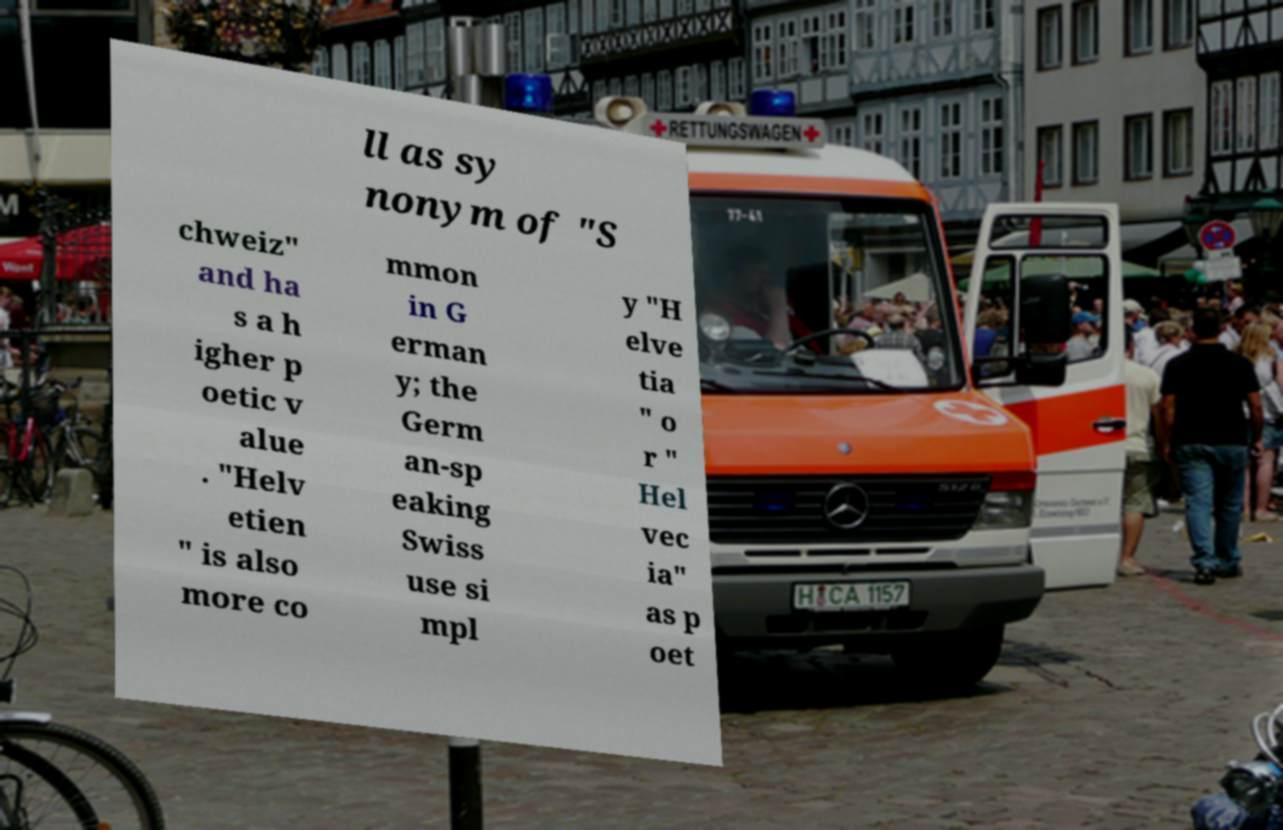I need the written content from this picture converted into text. Can you do that? ll as sy nonym of "S chweiz" and ha s a h igher p oetic v alue . "Helv etien " is also more co mmon in G erman y; the Germ an-sp eaking Swiss use si mpl y "H elve tia " o r " Hel vec ia" as p oet 